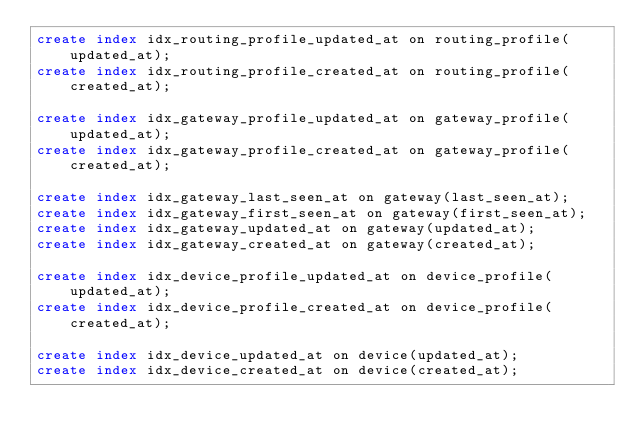Convert code to text. <code><loc_0><loc_0><loc_500><loc_500><_SQL_>create index idx_routing_profile_updated_at on routing_profile(updated_at);
create index idx_routing_profile_created_at on routing_profile(created_at);

create index idx_gateway_profile_updated_at on gateway_profile(updated_at);
create index idx_gateway_profile_created_at on gateway_profile(created_at);

create index idx_gateway_last_seen_at on gateway(last_seen_at);
create index idx_gateway_first_seen_at on gateway(first_seen_at);
create index idx_gateway_updated_at on gateway(updated_at);
create index idx_gateway_created_at on gateway(created_at);

create index idx_device_profile_updated_at on device_profile(updated_at);
create index idx_device_profile_created_at on device_profile(created_at);

create index idx_device_updated_at on device(updated_at);
create index idx_device_created_at on device(created_at);
</code> 